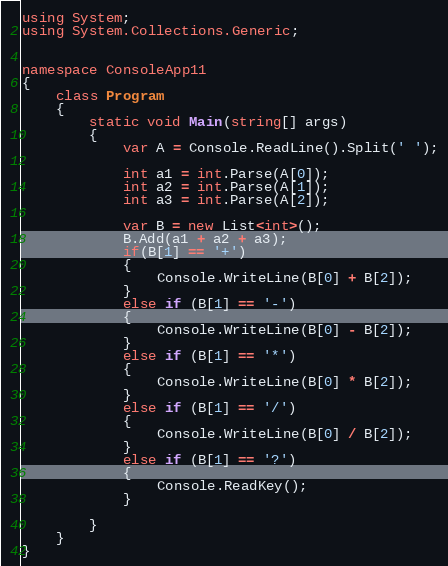<code> <loc_0><loc_0><loc_500><loc_500><_C#_>using System;
using System.Collections.Generic;


namespace ConsoleApp11
{
    class Program
    {
        static void Main(string[] args)
        {
            var A = Console.ReadLine().Split(' ');
            
            int a1 = int.Parse(A[0]);
            int a2 = int.Parse(A[1]);
            int a3 = int.Parse(A[2]);

            var B = new List<int>();
            B.Add(a1 + a2 + a3);
            if(B[1] == '+')
            {
                Console.WriteLine(B[0] + B[2]);
            }
            else if (B[1] == '-')
            {
                Console.WriteLine(B[0] - B[2]);
            }
            else if (B[1] == '*')
            {
                Console.WriteLine(B[0] * B[2]);
            }
            else if (B[1] == '/')
            {
                Console.WriteLine(B[0] / B[2]);
            }
            else if (B[1] == '?')
            {
                Console.ReadKey();
            }

        }
    }
}</code> 